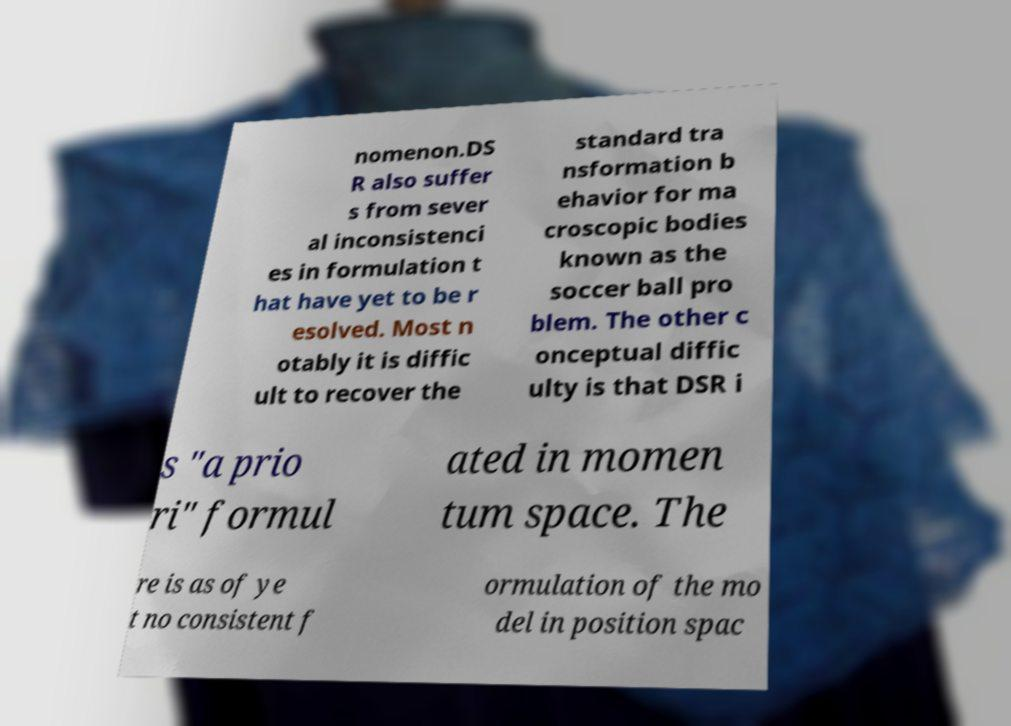I need the written content from this picture converted into text. Can you do that? nomenon.DS R also suffer s from sever al inconsistenci es in formulation t hat have yet to be r esolved. Most n otably it is diffic ult to recover the standard tra nsformation b ehavior for ma croscopic bodies known as the soccer ball pro blem. The other c onceptual diffic ulty is that DSR i s "a prio ri" formul ated in momen tum space. The re is as of ye t no consistent f ormulation of the mo del in position spac 